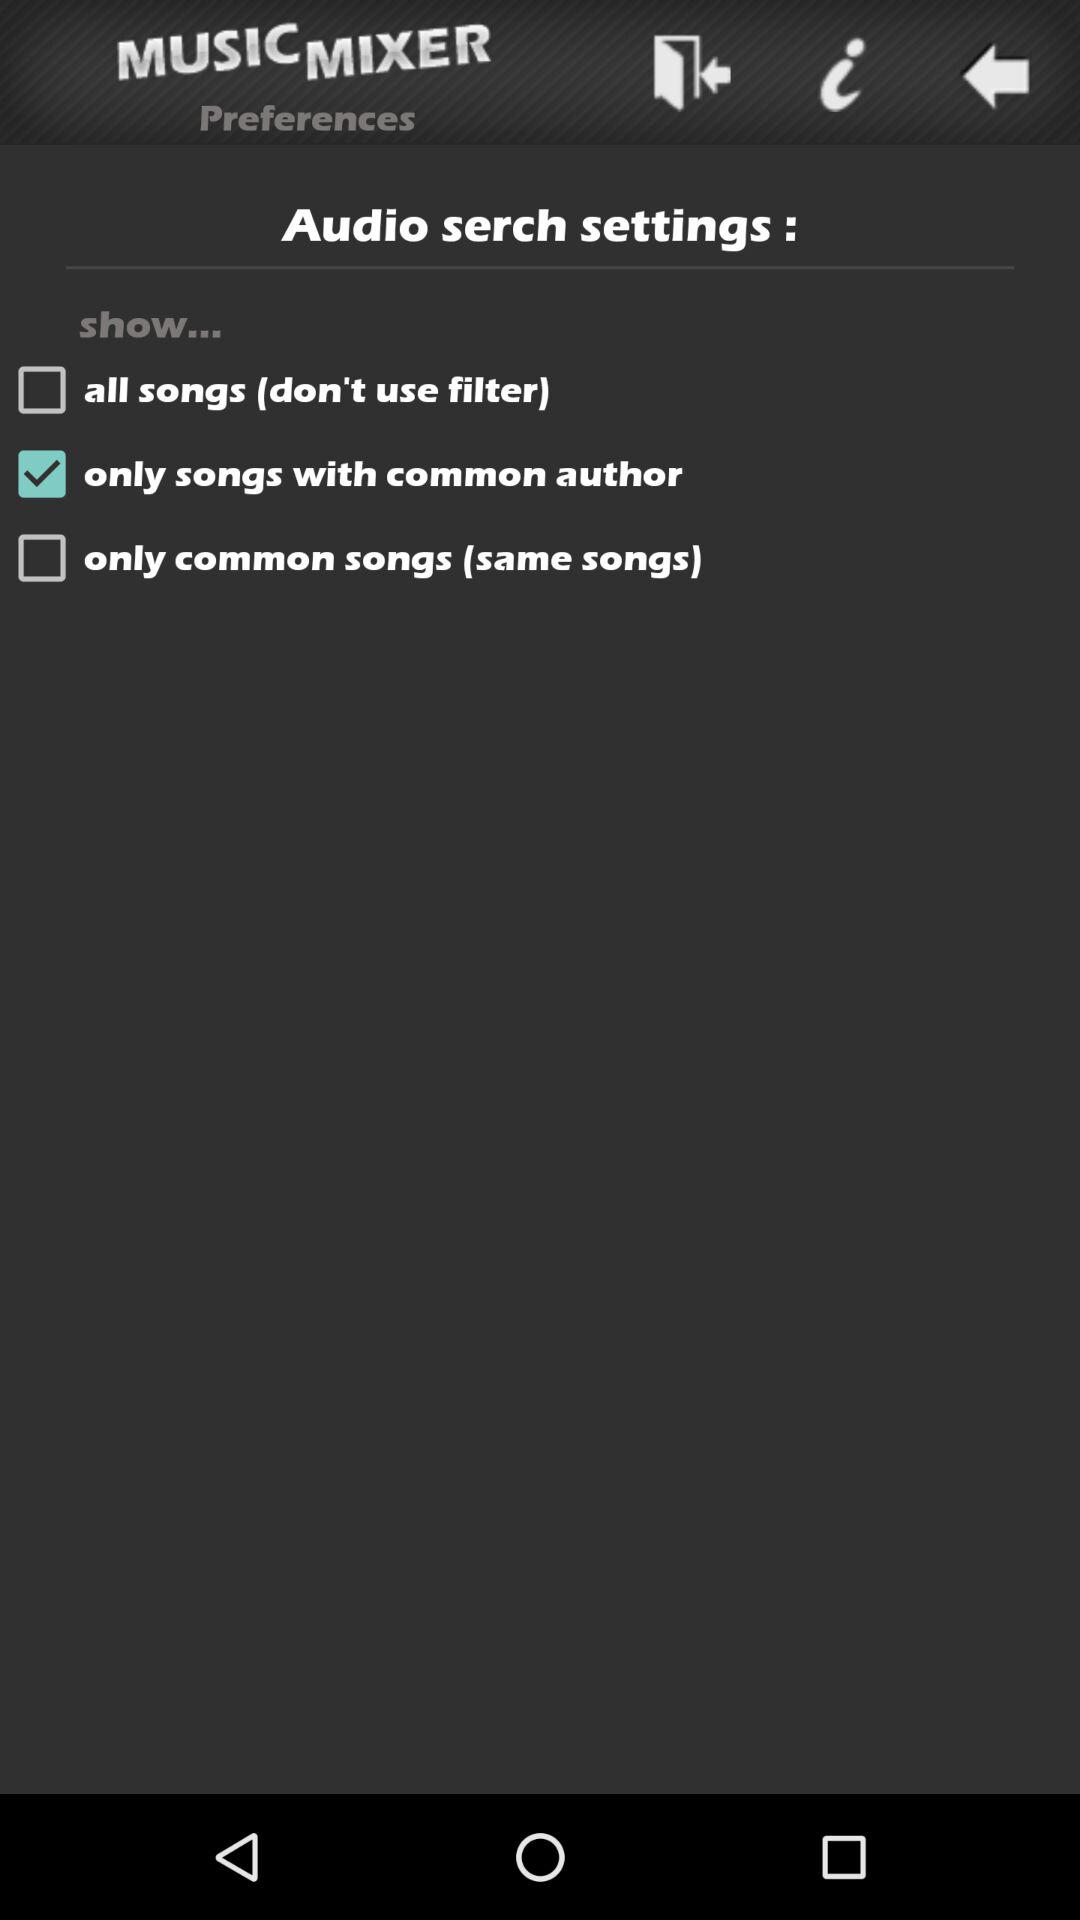Which option is selected for the audio setting? The option selected for the audio setting is "only songs with common author". 